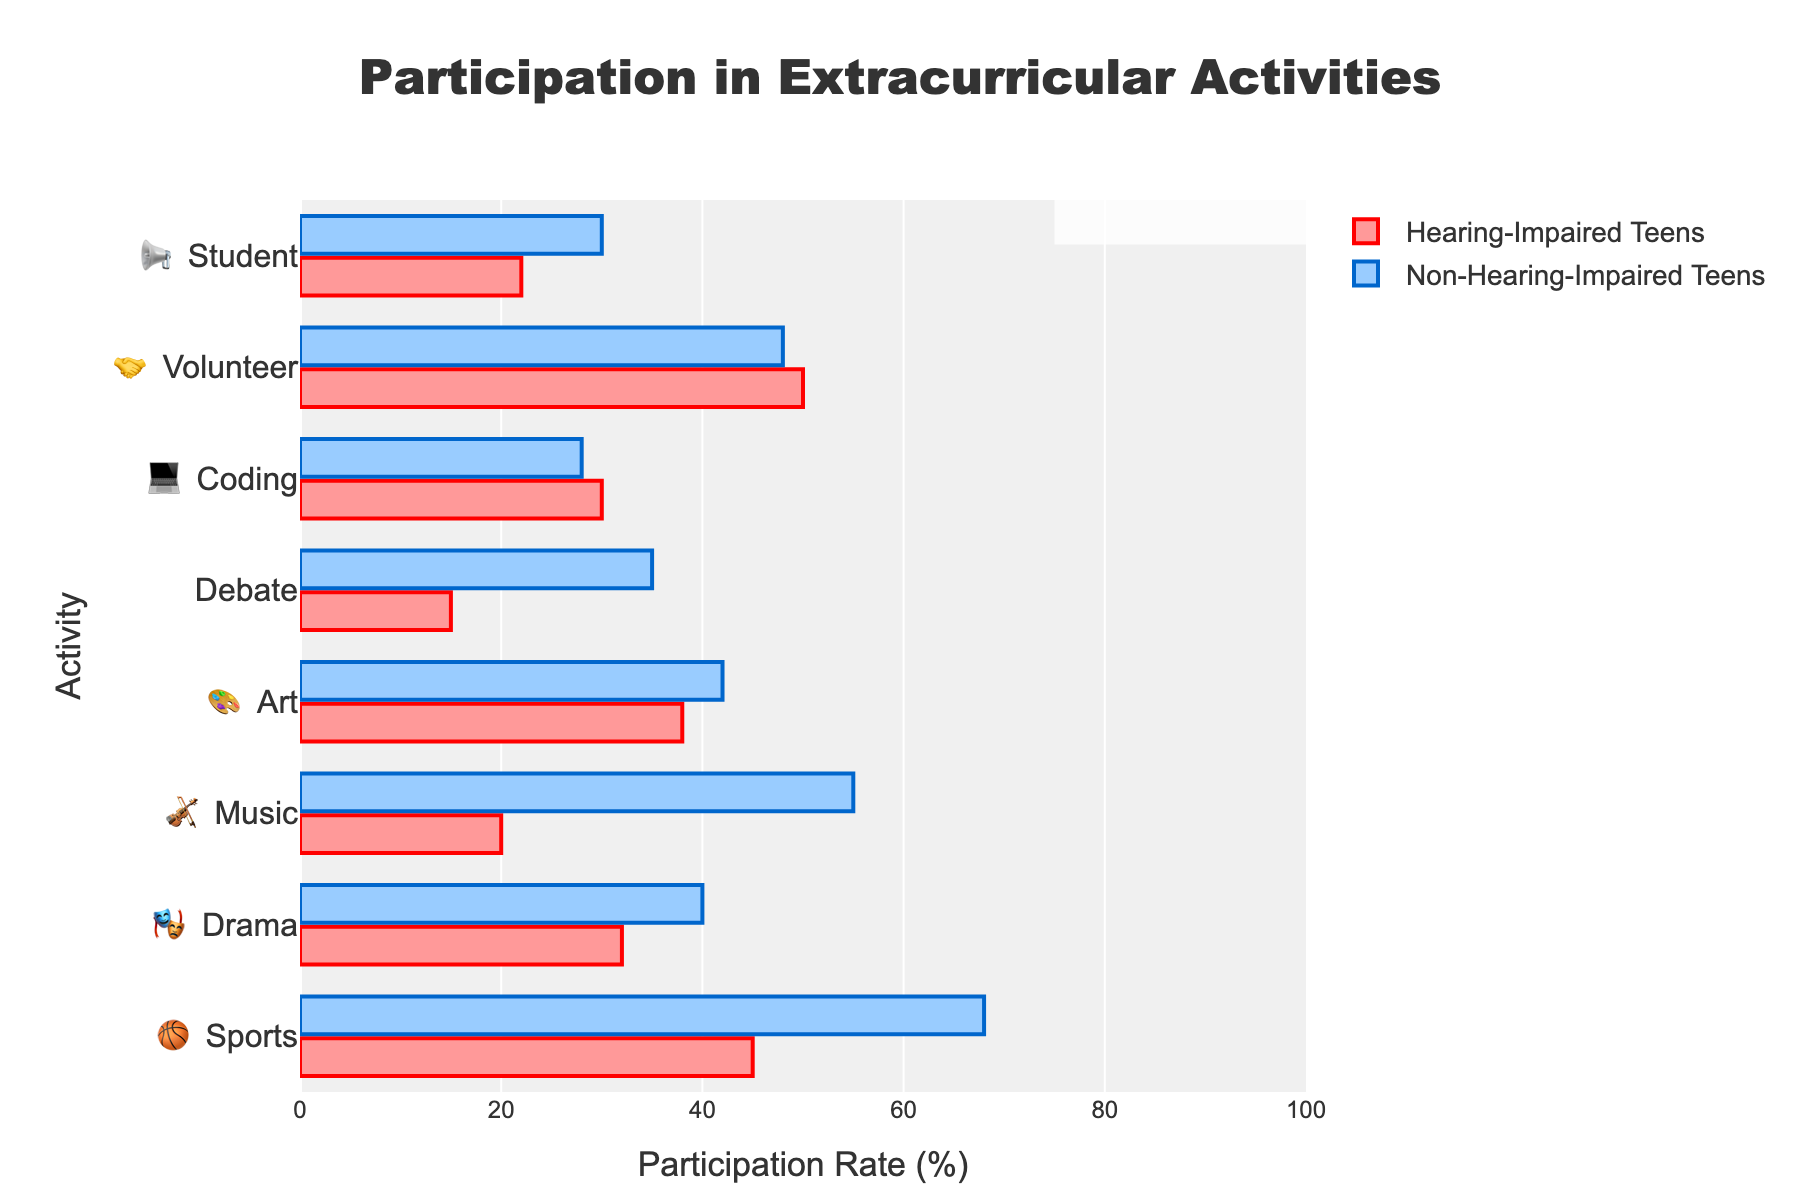what is the overall participation rate in the Coding Club for both groups? To find the overall participation rate, we add the rates of hearing-impaired and non-hearing-impaired teens and then divide by 2. (30% + 28%) / 2 = 29%
Answer: 29% Which activity has the highest participation rate among hearing-impaired teens? By looking at the plot, Volunteer Service 🤝 has the highest participation rate among hearing-impaired teens with 50%.
Answer: Volunteer Service 🤝 How much greater is the participation rate in Music Ensemble 🎻 for non-hearing-impaired teens compared to hearing-impaired teens? The participation rate for non-hearing-impaired teens in Music Ensemble 🎻 is 55%, and for hearing-impaired teens it is 20%. The difference is 55% - 20% = 35%.
Answer: 35% Which activity shows a higher participation rate for hearing-impaired teens than non-hearing-impaired teens? By examining the bars, Volunteer Service 🤝 and Coding Club 💻 show higher participation rates for hearing-impaired teens. Volunteer Service 🤝 has 50% vs 48%, and Coding Club 💻 has 30% vs 28%.
Answer: Volunteer Service 🤝 and Coding Club 💻 What is the overall average participation rate in Sports 🏀 for both groups? Add the participation rates for both groups (45% + 68%) and divide by 2. (45% + 68%) / 2 = 56.5%
Answer: 56.5% Which activity has the lowest participation rate among hearing-impaired teens? The activity with the lowest participation rate among hearing-impaired teens is the Debate Team 🗣️ with 15%.
Answer: Debate Team 🗣️ Is the participation rate in Art Club 🎨 higher for non-hearing-impaired teens or hearing-impaired teens? Comparing the participation rates for Art Club 🎨, non-hearing-impaired teens have 42% and hearing-impaired teens have 38%. Non-hearing-impaired teens have a higher rate.
Answer: non-hearing-impaired teens Among hearing-impaired teens, which has a higher participation rate, Drama Club 🎭 or Student Council 📢? Comparing the rates, Drama Club 🎭 has 32% and Student Council 📢 has 22%. Drama Club 🎭 has a higher participation rate.
Answer: Drama Club 🎭 What is the combined participation rate for both groups in Debate Team 🗣️? Add the participation rates for both groups: 15% (hearing-impaired) + 35% (non-hearing-impaired) = 50%
Answer: 50% How many activities have higher participation rates for hearing-impaired teens compared to non-hearing-impaired teens? By examining the bars, two activities, Volunteer Service 🤝 and Coding Club 💻 have higher participation rates for hearing-impaired teens.
Answer: 2 